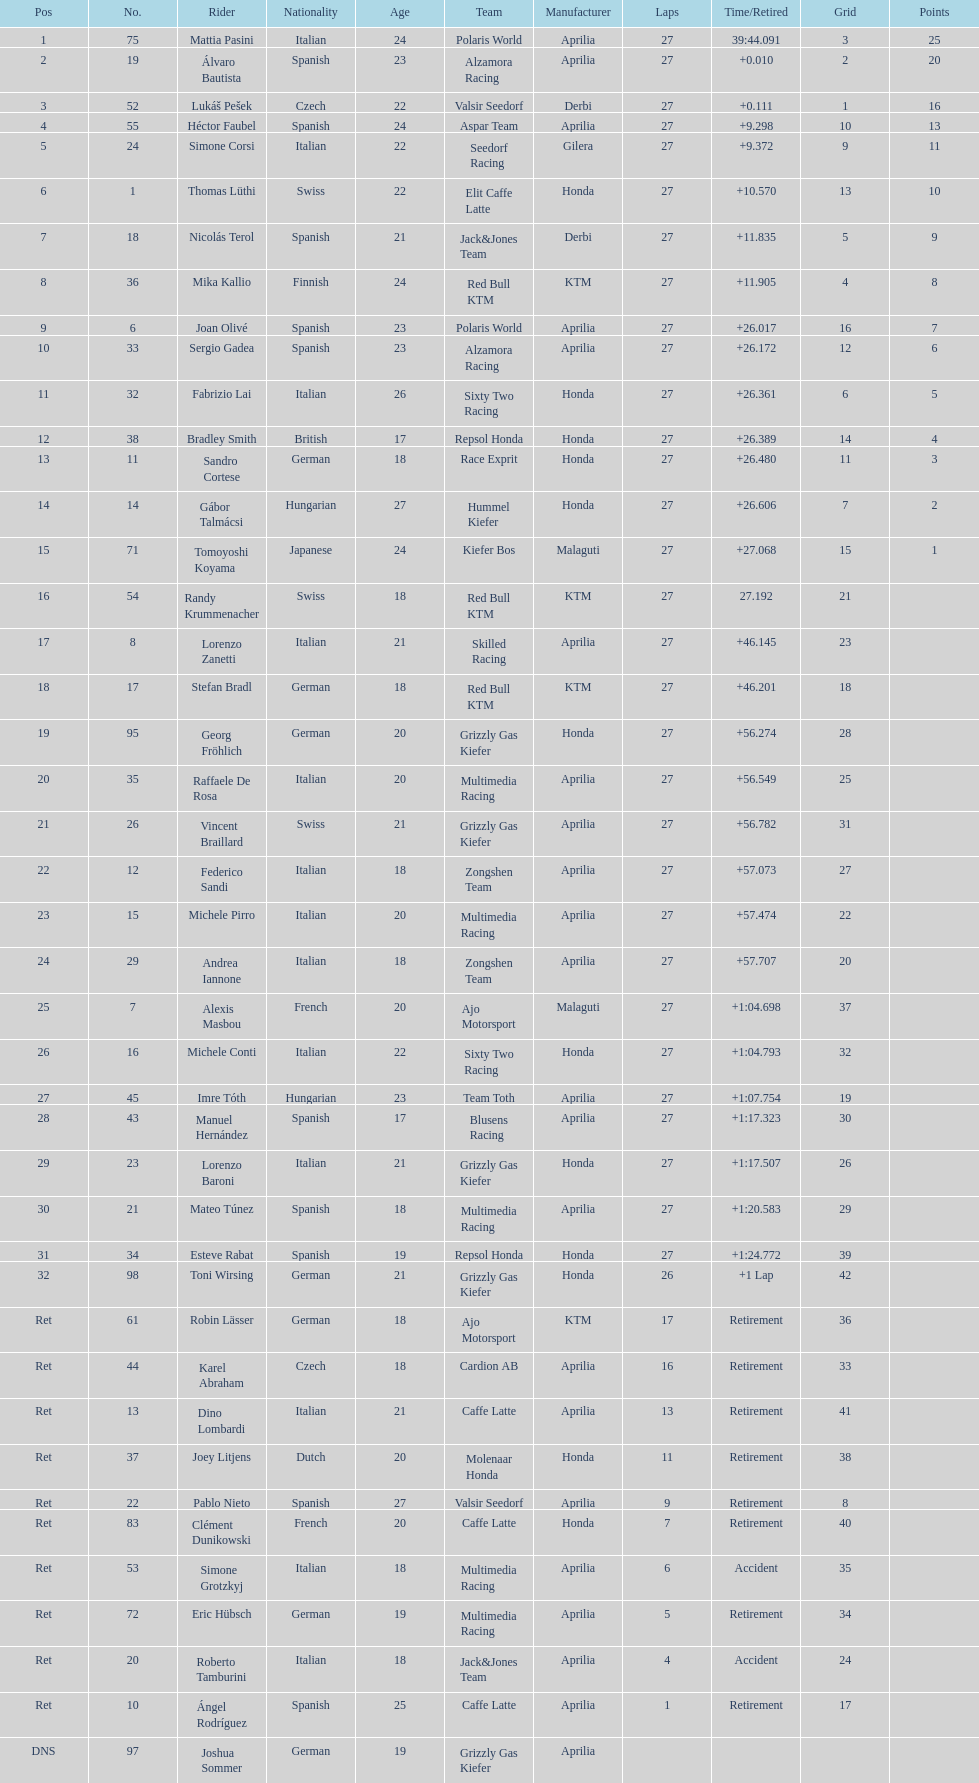Which rider came in first with 25 points? Mattia Pasini. 